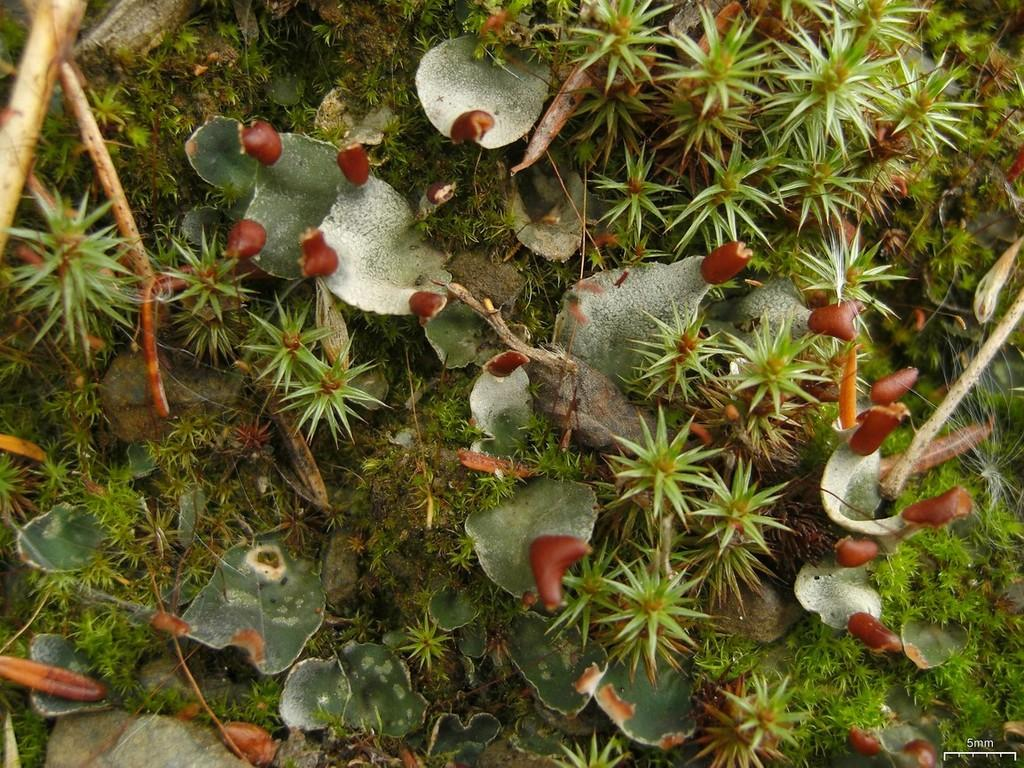What type of living organisms can be seen in the image? Plants can be seen in the image. What colors are the plants in the image? The plants are green and red in color. Where are the plants located in the image? The plants are on the ground. What other objects can be seen in the image? There are wooden sticks in the image. What color are the wooden sticks? The wooden sticks are brown in color. What type of apparel is being worn by the plants in the image? There are no people or animals wearing apparel in the image; it features plants and wooden sticks. 